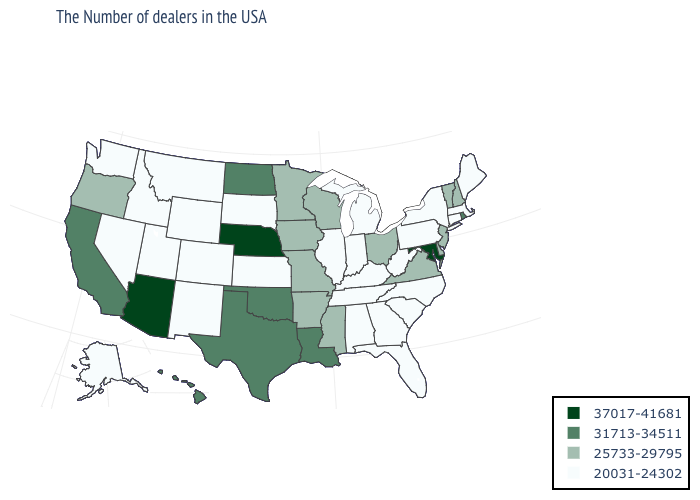What is the value of Tennessee?
Concise answer only. 20031-24302. What is the value of New Mexico?
Be succinct. 20031-24302. What is the value of Wyoming?
Keep it brief. 20031-24302. What is the highest value in states that border Texas?
Keep it brief. 31713-34511. Does Washington have a lower value than New Mexico?
Be succinct. No. Among the states that border Iowa , does Minnesota have the lowest value?
Be succinct. No. What is the highest value in the USA?
Be succinct. 37017-41681. Which states have the highest value in the USA?
Write a very short answer. Maryland, Nebraska, Arizona. Which states have the highest value in the USA?
Short answer required. Maryland, Nebraska, Arizona. Name the states that have a value in the range 31713-34511?
Give a very brief answer. Rhode Island, Louisiana, Oklahoma, Texas, North Dakota, California, Hawaii. Does Arkansas have the same value as New Mexico?
Concise answer only. No. Which states have the lowest value in the USA?
Quick response, please. Maine, Massachusetts, Connecticut, New York, Pennsylvania, North Carolina, South Carolina, West Virginia, Florida, Georgia, Michigan, Kentucky, Indiana, Alabama, Tennessee, Illinois, Kansas, South Dakota, Wyoming, Colorado, New Mexico, Utah, Montana, Idaho, Nevada, Washington, Alaska. Does Indiana have a lower value than Iowa?
Concise answer only. Yes. What is the lowest value in the Northeast?
Give a very brief answer. 20031-24302. Name the states that have a value in the range 25733-29795?
Concise answer only. New Hampshire, Vermont, New Jersey, Delaware, Virginia, Ohio, Wisconsin, Mississippi, Missouri, Arkansas, Minnesota, Iowa, Oregon. 